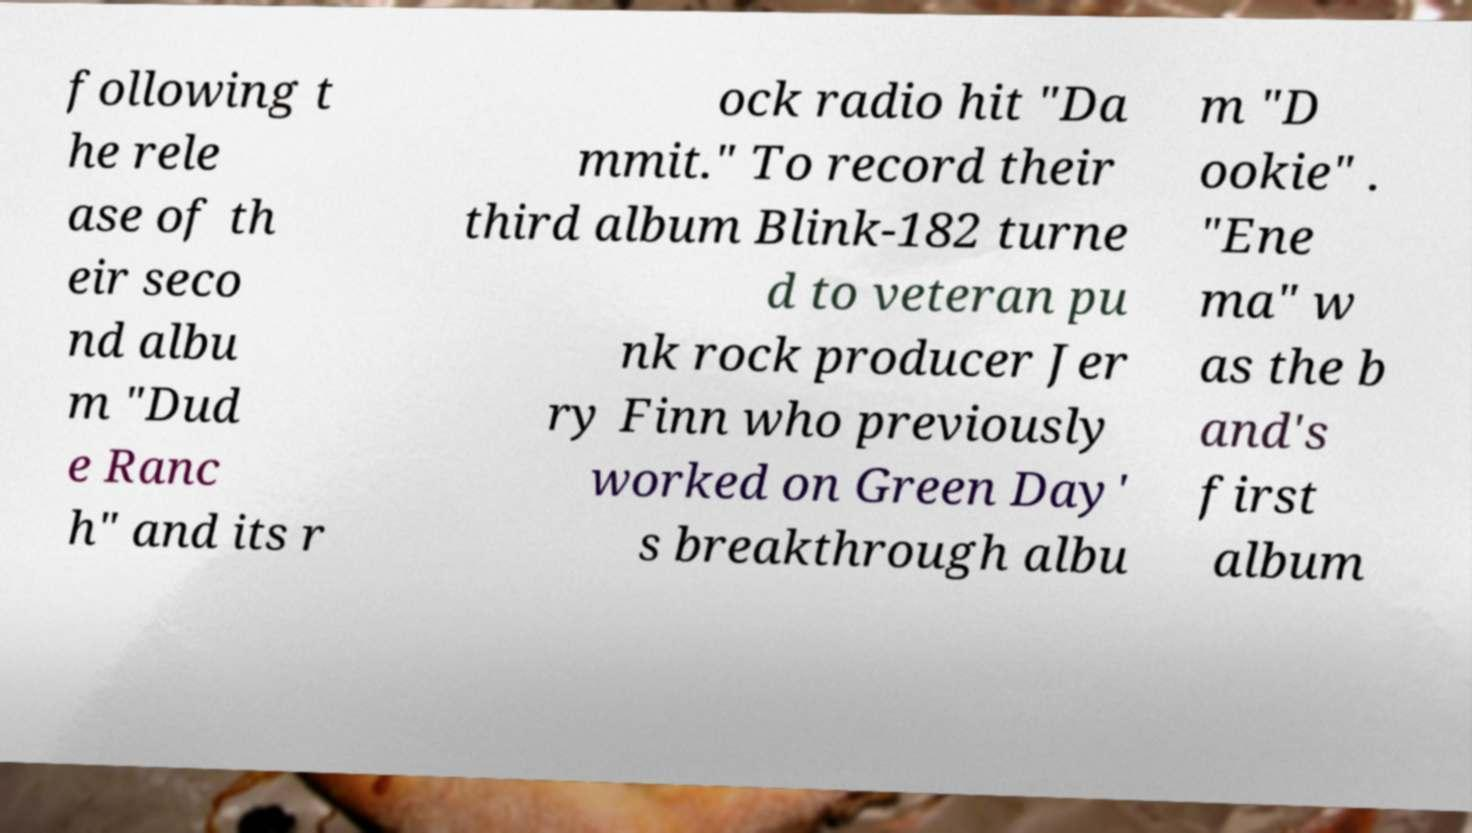Please read and relay the text visible in this image. What does it say? following t he rele ase of th eir seco nd albu m "Dud e Ranc h" and its r ock radio hit "Da mmit." To record their third album Blink-182 turne d to veteran pu nk rock producer Jer ry Finn who previously worked on Green Day' s breakthrough albu m "D ookie" . "Ene ma" w as the b and's first album 